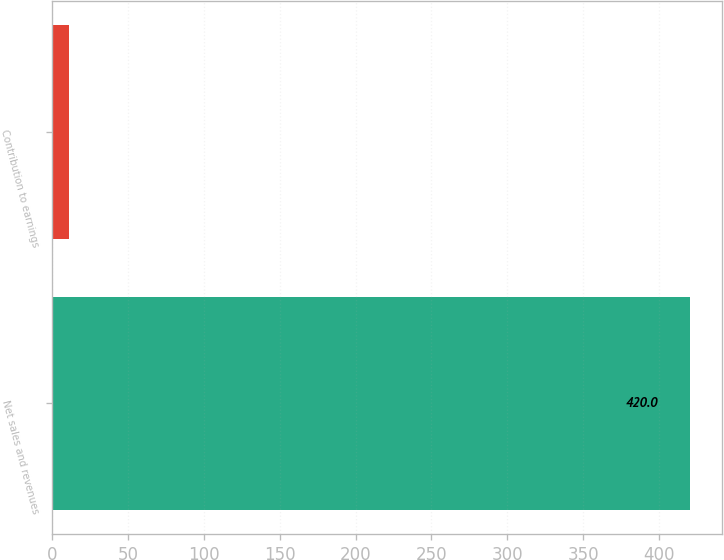Convert chart to OTSL. <chart><loc_0><loc_0><loc_500><loc_500><bar_chart><fcel>Net sales and revenues<fcel>Contribution to earnings<nl><fcel>420<fcel>11<nl></chart> 